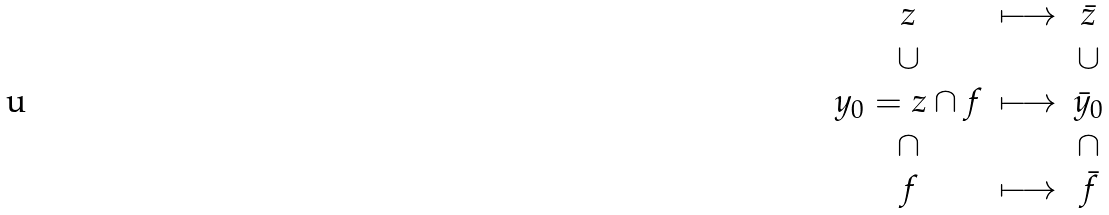<formula> <loc_0><loc_0><loc_500><loc_500>\begin{matrix} z & \longmapsto & \bar { z } \\ \cup & & \cup \\ y _ { 0 } = z \cap f & \longmapsto & \bar { y } _ { 0 } \\ \cap & & \cap \\ f & \longmapsto & \bar { f } \\ \end{matrix}</formula> 